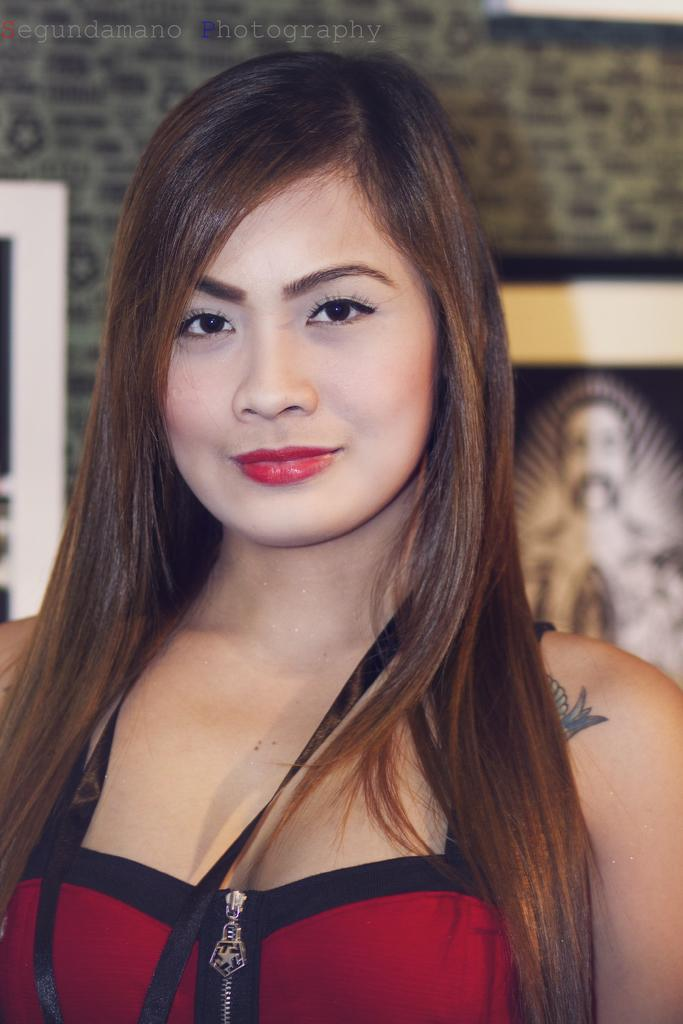What is the woman in the image wearing? The woman is wearing a red dress. What expression does the woman have in the image? The woman is smiling. What is the woman doing in the image? The woman is giving a pose for the picture. What can be seen in the background of the image? There is a frame attached to the wall in the background of the image. What type of worm can be seen crawling on the woman's dress in the image? There is no worm present in the image; the woman is wearing a red dress. 